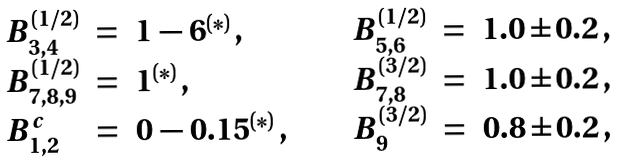Convert formula to latex. <formula><loc_0><loc_0><loc_500><loc_500>\begin{array} { l c l c l c l } { { B _ { 3 , 4 } ^ { ( 1 / 2 ) } } } & { = } & { { 1 \, - \, 6 ^ { ( * ) } \, , } } & { \quad } & { { B _ { 5 , 6 } ^ { ( 1 / 2 ) } } } & { = } & { 1 . 0 \pm 0 . 2 \, , } \\ { { B _ { 7 , 8 , 9 } ^ { ( 1 / 2 ) } } } & { = } & { { 1 ^ { ( * ) } \, , } } & { \quad } & { { B _ { 7 , 8 } ^ { ( 3 / 2 ) } } } & { = } & { 1 . 0 \pm 0 . 2 \, , } \\ { { B _ { 1 , 2 } ^ { c } } } & { = } & { { 0 \, - \, 0 . 1 5 ^ { ( * ) } \, , } } & { \quad } & { { B _ { 9 } ^ { ( 3 / 2 ) } } } & { = } & { 0 . 8 \pm 0 . 2 \, , } \end{array}</formula> 